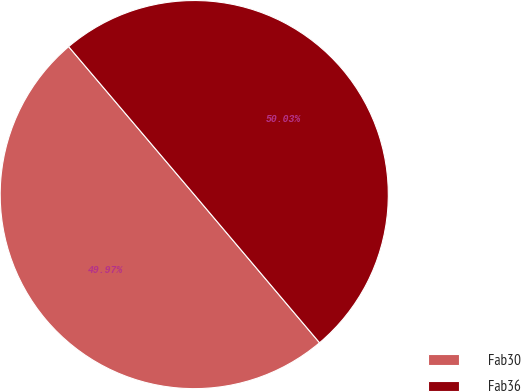Convert chart to OTSL. <chart><loc_0><loc_0><loc_500><loc_500><pie_chart><fcel>Fab30<fcel>Fab36<nl><fcel>49.97%<fcel>50.03%<nl></chart> 